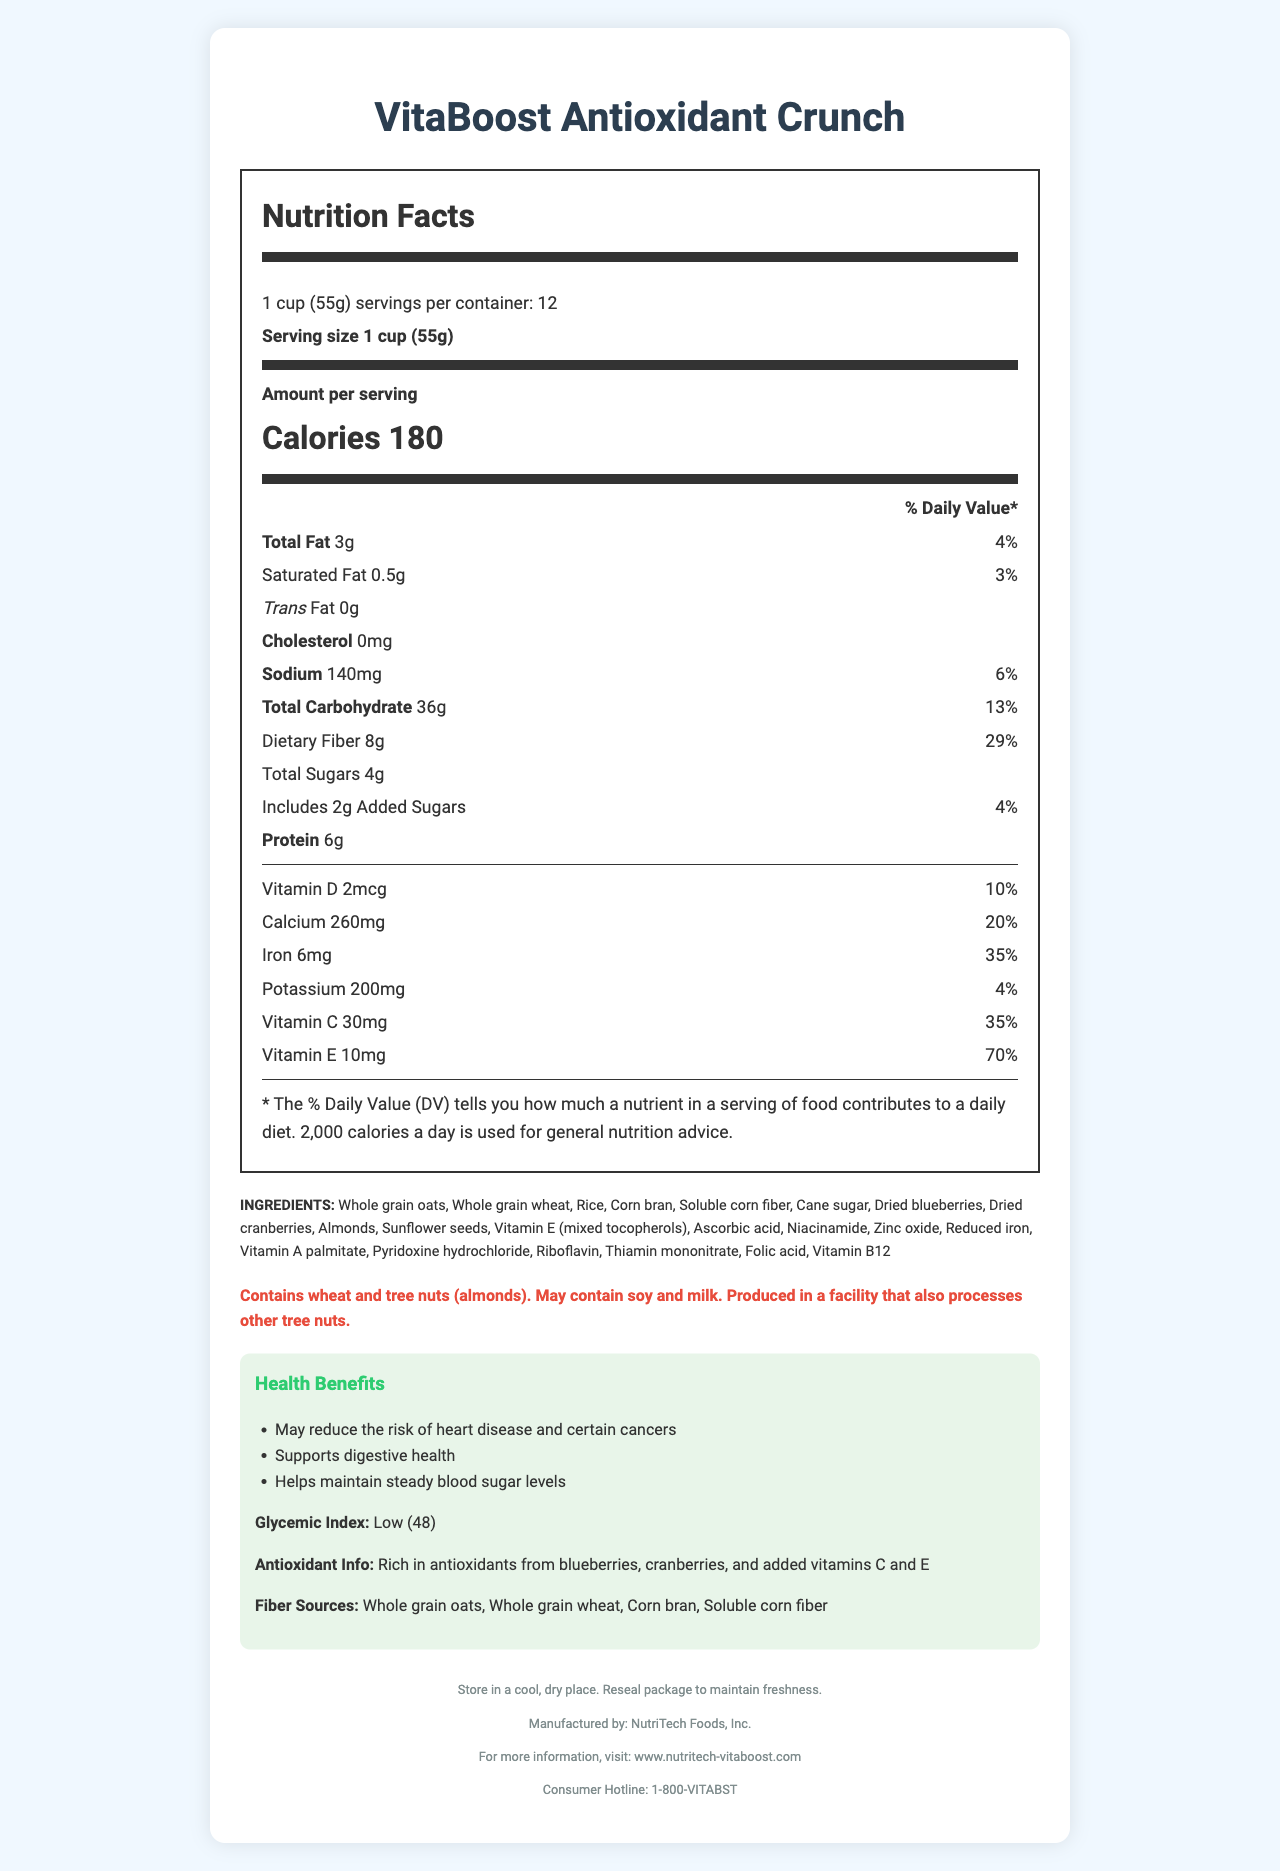what is the serving size of the cereal? The serving size is clearly mentioned at the top of the Nutrition Facts label as "1 cup (55g)."
Answer: 1 cup (55g) how many servings are in the container? The number of servings per container is explicitly noted as 12.
Answer: 12 what is the total fat content per serving? The total fat content is listed as "3g" under the "Total Fat" section.
Answer: 3g how much sodium does one serving of the cereal contain? Sodium is listed as "140mg" next to the word "Sodium" in the nutrition label.
Answer: 140mg what is the percentage daily value of iron provided by one serving? The daily value percentage for iron is listed as "35%" alongside the iron content information.
Answer: 35% what is the amount of dietary fiber in each serving? The dietary fiber content is listed as "8g" under the "Total Carbohydrate" section.
Answer: 8g what are the main sources of fiber in this cereal? A. Whole grain oats, Whole grain wheat, Corn bran, Soluble corn fiber B. Whole grain oats, Sugar, Cinnamon, Rice C. Whole grain wheat, Soy, Milk, Whole grain oats The main sources of fiber indicated are "Whole grain oats, Whole grain wheat, Corn bran, Soluble corn fiber."
Answer: A what vitamins are added to this cereal? I. Vitamin D II. Vitamin C III. Vitamin E IV. Vitamin B12 The document lists Vitamin D, Vitamin C, Vitamin E, and Vitamin B12 among the ingredients and the % daily value section.
Answer: All of the above is this cereal gluten-free? The allergen info indicates that the cereal contains wheat, which means it is not gluten-free.
Answer: No summarize the health claims of this cereal. The health claims section lists these specific benefits and provides supportive information about its low glycemic index and rich antioxidant content.
Answer: May reduce the risk of heart disease and certain cancers, Supports digestive health, Helps maintain steady blood sugar levels how should the cereal be stored to maintain its freshness? The storage instructions are explicitly provided at the end of the document.
Answer: Store in a cool, dry place. Reseal package to maintain freshness. what are the potential allergens present in the cereal? The allergen information provides this detail in the designated allergen-info section.
Answer: Wheat and tree nuts (almonds), may contain soy and milk, produced in a facility that also processes other tree nuts what is the glycemic index of this cereal? The glycemic index is listed as "Low (48)" in the health benefits section.
Answer: 48 (Low) which company manufactures VitaBoost Antioxidant Crunch? The manufacturer's information is provided at the bottom of the document.
Answer: NutriTech Foods, Inc. how many calories are in one serving of the cereal? The calorie content is displayed as "Calories 180" prominently in the nutrition label.
Answer: 180 does this cereal help in supporting digestive health? The health claims section explicitly mentions that the cereal supports digestive health.
Answer: Yes does the cereal contain any artificial colors or flavors? The document does not provide information about artificial colors or flavors; it only lists the specific ingredients used.
Answer: Cannot be determined 